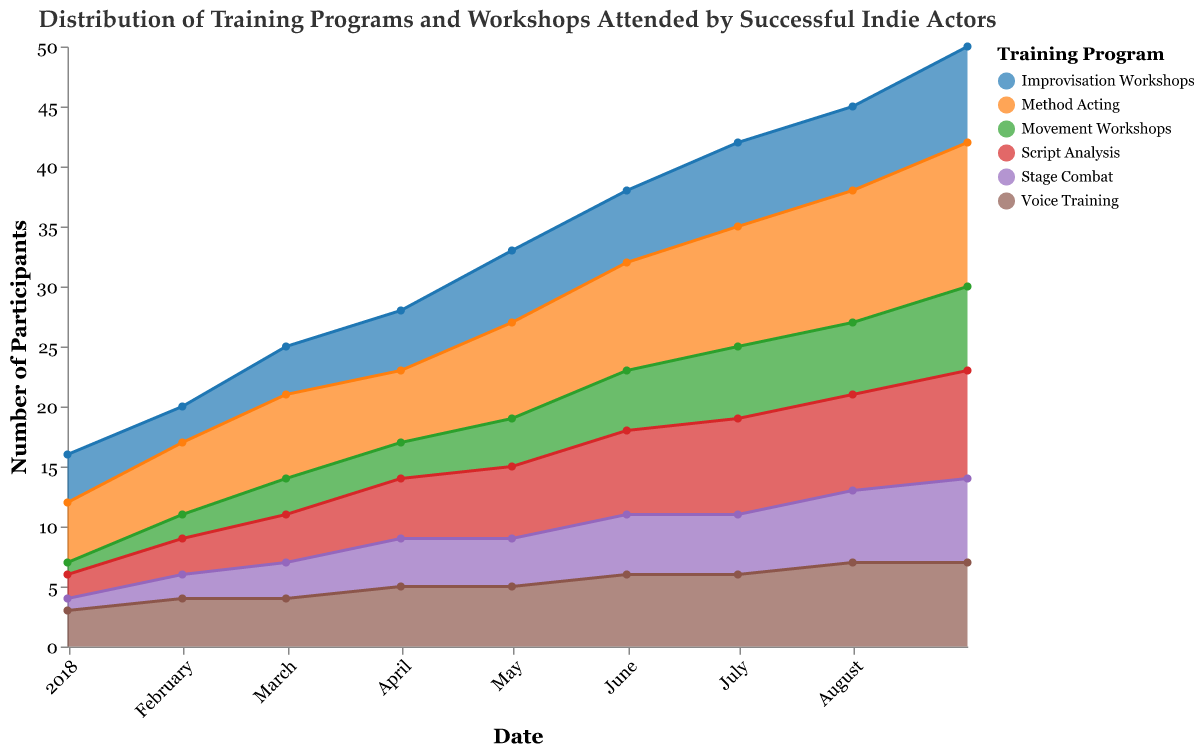What is the title of the chart? The title can be found at the top of the chart which is "Distribution of Training Programs and Workshops Attended by Successful Indie Actors".
Answer: Distribution of Training Programs and Workshops Attended by Successful Indie Actors How many participants attended the Voice Training workshops in July 2018? From the chart, locate July 2018 on the x-axis and check the y-value for Voice Training. It shows 6 participants.
Answer: 6 Which training program had the highest number of participants in August 2018? Identify the program with the highest area in August 2018 by comparing the stacked segments. Method Acting had the highest value of 11.
Answer: Method Acting By how many participants did Script Analysis workshops increase from February 2018 to June 2018? For February 2018, Script Analysis had 3 participants. For June 2018, it had 7 participants. The increase is 7 - 3 = 4.
Answer: 4 Which training program saw the most consistent increase in the number of participants over the period? By examining the slopes of the areas, Method Acting shows a consistent increase evidenced by a steadily growing area over time.
Answer: Method Acting What is the total number of participants attending Stage Combat workshops over the entire period? Sum the values of Stage Combat for each month: 1+2+3+4+4+5+5+6+7 = 37.
Answer: 37 Which month experienced the same number of participants in Improvisation Workshops and Script Analysis workshops? Locate and compare the values of Improvisation Workshops and Script Analysis for each month. Both had 8 participants in September 2018.
Answer: September 2018 How does the number of participants in Movement Workshops compare from January to September 2018? Compare the area heights for Movement Workshops from January with that in September. The number increased from 1 in January to 7 in September, showing growth.
Answer: Increased What is the average number of participants for Method Acting across all months presented? Sum the values of Method Acting for each month: 5+6+7+6+8+9+10+11+12 = 74. Divide by the number of months, (74/9 ≈ 8.22).
Answer: Approximately 8.22 How do the numbers of participants compare between Voice Training and Movement Workshops in May 2018? Locate May 2018 on the x-axis and compare the y-values for Voice Training (5) and Movement Workshops (4). Voice Training had more participants.
Answer: Voice Training had more participants 